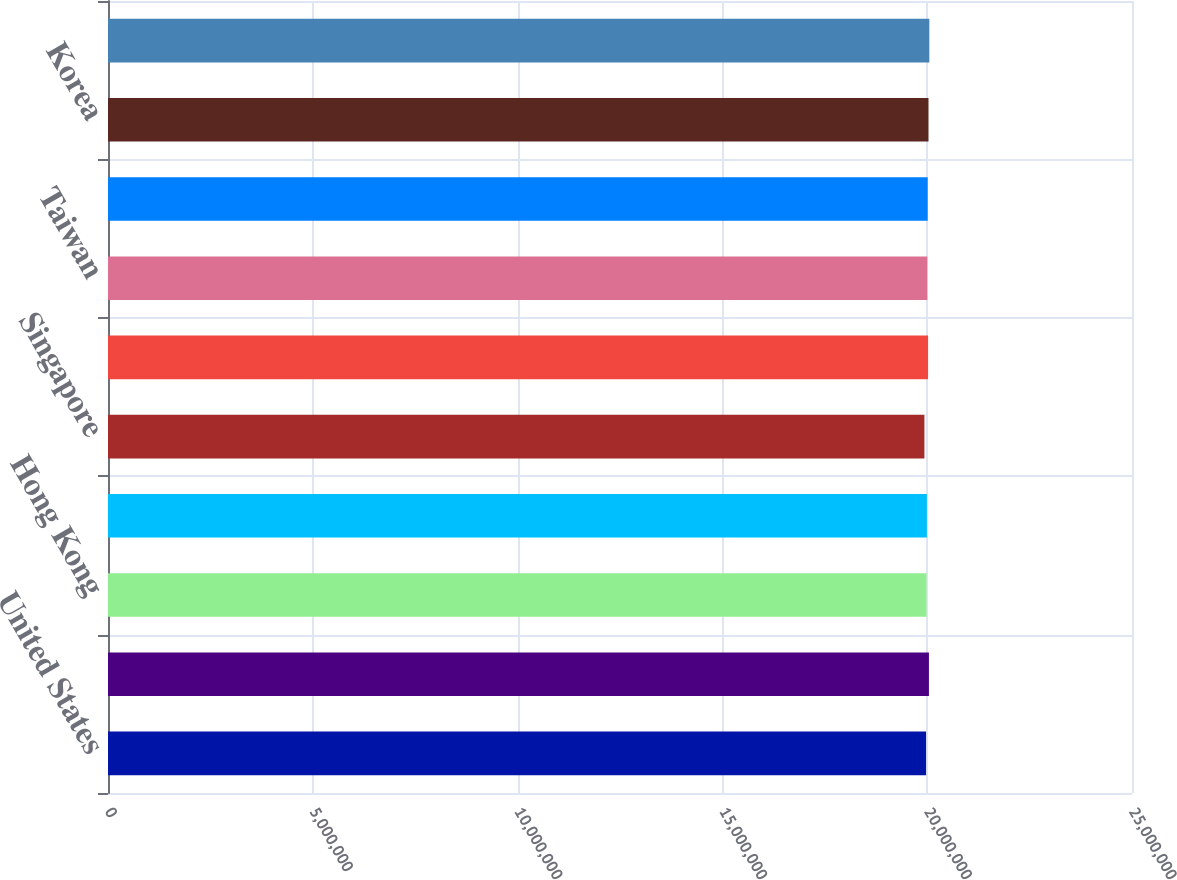Convert chart to OTSL. <chart><loc_0><loc_0><loc_500><loc_500><bar_chart><fcel>United States<fcel>United Kingdom<fcel>Hong Kong<fcel>Malaysia<fcel>Singapore<fcel>Thailand<fcel>Taiwan<fcel>Japan<fcel>Korea<fcel>France<nl><fcel>1.9972e+07<fcel>2.0042e+07<fcel>1.9982e+07<fcel>1.9992e+07<fcel>1.9932e+07<fcel>2.0022e+07<fcel>2.0002e+07<fcel>2.0012e+07<fcel>2.0032e+07<fcel>2.0052e+07<nl></chart> 